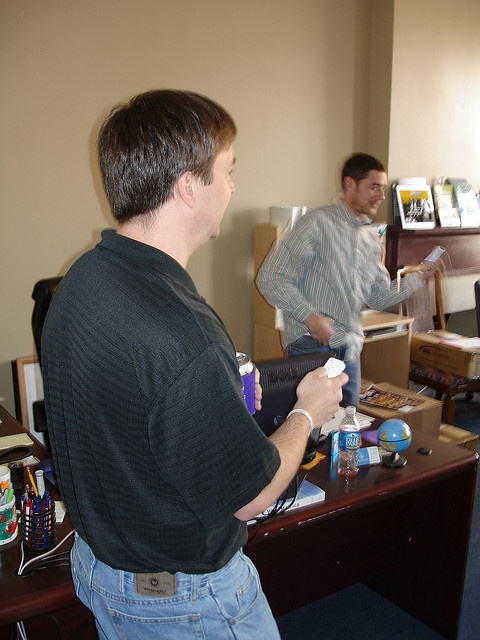Describe the objects in this image and their specific colors. I can see people in gray, black, and tan tones, people in gray, darkgray, and black tones, tv in gray and black tones, chair in gray, black, and maroon tones, and chair in gray, darkgray, and black tones in this image. 